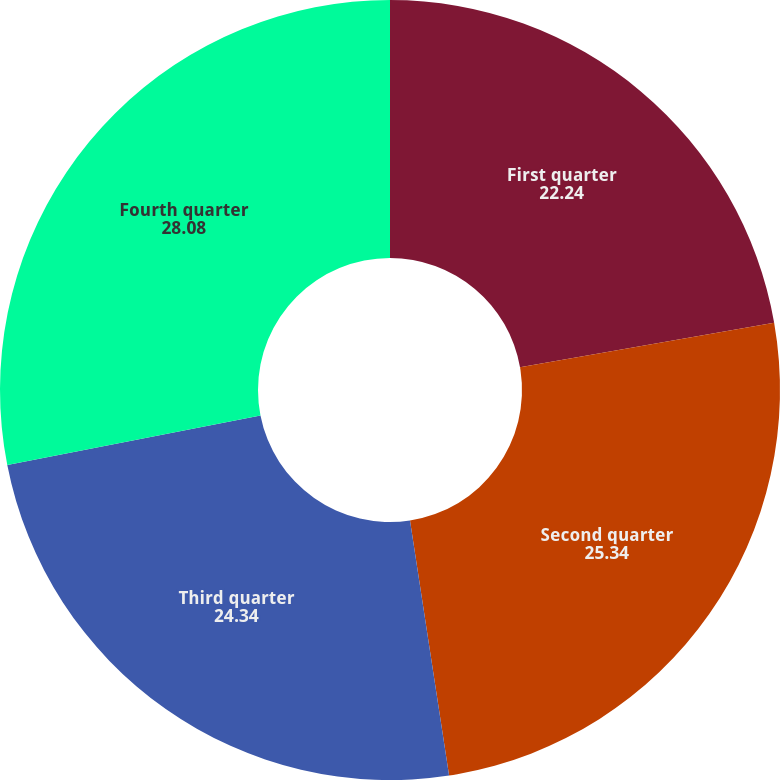Convert chart. <chart><loc_0><loc_0><loc_500><loc_500><pie_chart><fcel>First quarter<fcel>Second quarter<fcel>Third quarter<fcel>Fourth quarter<nl><fcel>22.24%<fcel>25.34%<fcel>24.34%<fcel>28.08%<nl></chart> 